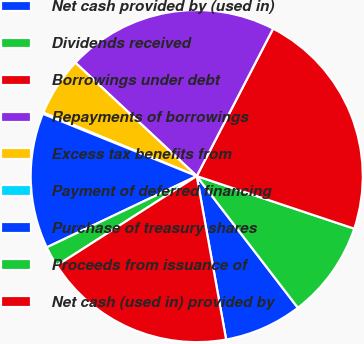<chart> <loc_0><loc_0><loc_500><loc_500><pie_chart><fcel>Net cash provided by (used in)<fcel>Dividends received<fcel>Borrowings under debt<fcel>Repayments of borrowings<fcel>Excess tax benefits from<fcel>Payment of deferred financing<fcel>Purchase of treasury shares<fcel>Proceeds from issuance of<fcel>Net cash (used in) provided by<nl><fcel>7.59%<fcel>9.45%<fcel>22.52%<fcel>20.65%<fcel>5.72%<fcel>0.12%<fcel>13.18%<fcel>1.99%<fcel>18.78%<nl></chart> 